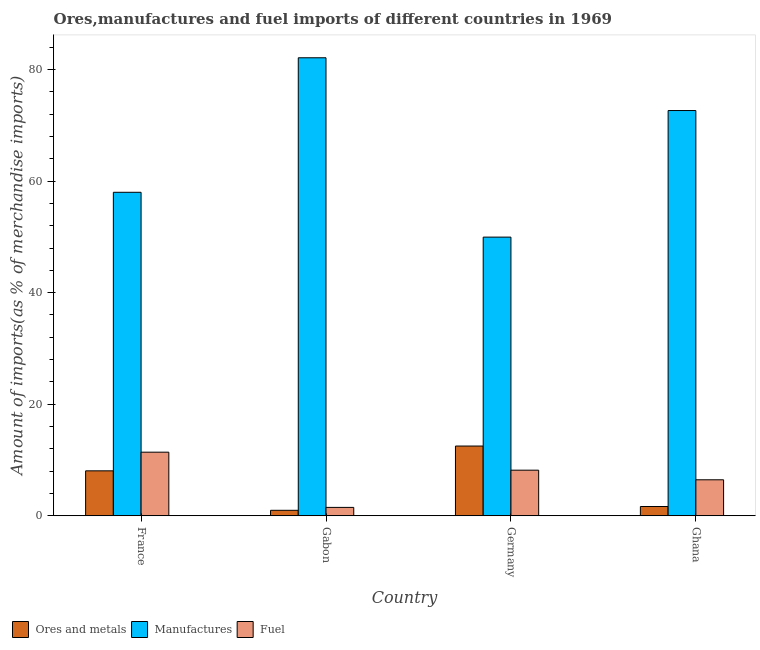How many bars are there on the 4th tick from the right?
Ensure brevity in your answer.  3. What is the label of the 3rd group of bars from the left?
Your response must be concise. Germany. What is the percentage of manufactures imports in Gabon?
Your response must be concise. 82.11. Across all countries, what is the maximum percentage of ores and metals imports?
Your answer should be compact. 12.5. Across all countries, what is the minimum percentage of ores and metals imports?
Offer a very short reply. 0.98. In which country was the percentage of manufactures imports maximum?
Give a very brief answer. Gabon. In which country was the percentage of fuel imports minimum?
Ensure brevity in your answer.  Gabon. What is the total percentage of ores and metals imports in the graph?
Keep it short and to the point. 23.21. What is the difference between the percentage of fuel imports in France and that in Germany?
Give a very brief answer. 3.23. What is the difference between the percentage of ores and metals imports in Gabon and the percentage of fuel imports in Germany?
Your answer should be very brief. -7.19. What is the average percentage of ores and metals imports per country?
Ensure brevity in your answer.  5.8. What is the difference between the percentage of fuel imports and percentage of ores and metals imports in Germany?
Keep it short and to the point. -4.33. In how many countries, is the percentage of manufactures imports greater than 76 %?
Your answer should be compact. 1. What is the ratio of the percentage of ores and metals imports in France to that in Ghana?
Your response must be concise. 4.84. What is the difference between the highest and the second highest percentage of fuel imports?
Keep it short and to the point. 3.23. What is the difference between the highest and the lowest percentage of ores and metals imports?
Your response must be concise. 11.52. What does the 2nd bar from the left in France represents?
Give a very brief answer. Manufactures. What does the 2nd bar from the right in France represents?
Your answer should be compact. Manufactures. Is it the case that in every country, the sum of the percentage of ores and metals imports and percentage of manufactures imports is greater than the percentage of fuel imports?
Your answer should be compact. Yes. How many bars are there?
Ensure brevity in your answer.  12. How many countries are there in the graph?
Offer a terse response. 4. What is the difference between two consecutive major ticks on the Y-axis?
Your response must be concise. 20. Does the graph contain any zero values?
Your answer should be compact. No. Where does the legend appear in the graph?
Provide a succinct answer. Bottom left. How are the legend labels stacked?
Your answer should be very brief. Horizontal. What is the title of the graph?
Ensure brevity in your answer.  Ores,manufactures and fuel imports of different countries in 1969. Does "Liquid fuel" appear as one of the legend labels in the graph?
Make the answer very short. No. What is the label or title of the Y-axis?
Provide a succinct answer. Amount of imports(as % of merchandise imports). What is the Amount of imports(as % of merchandise imports) in Ores and metals in France?
Give a very brief answer. 8.06. What is the Amount of imports(as % of merchandise imports) in Manufactures in France?
Offer a terse response. 57.99. What is the Amount of imports(as % of merchandise imports) of Fuel in France?
Give a very brief answer. 11.4. What is the Amount of imports(as % of merchandise imports) in Ores and metals in Gabon?
Ensure brevity in your answer.  0.98. What is the Amount of imports(as % of merchandise imports) in Manufactures in Gabon?
Provide a short and direct response. 82.11. What is the Amount of imports(as % of merchandise imports) in Fuel in Gabon?
Provide a short and direct response. 1.51. What is the Amount of imports(as % of merchandise imports) in Ores and metals in Germany?
Give a very brief answer. 12.5. What is the Amount of imports(as % of merchandise imports) in Manufactures in Germany?
Offer a very short reply. 49.96. What is the Amount of imports(as % of merchandise imports) of Fuel in Germany?
Your answer should be compact. 8.18. What is the Amount of imports(as % of merchandise imports) in Ores and metals in Ghana?
Keep it short and to the point. 1.67. What is the Amount of imports(as % of merchandise imports) of Manufactures in Ghana?
Provide a succinct answer. 72.65. What is the Amount of imports(as % of merchandise imports) of Fuel in Ghana?
Offer a terse response. 6.45. Across all countries, what is the maximum Amount of imports(as % of merchandise imports) in Ores and metals?
Offer a very short reply. 12.5. Across all countries, what is the maximum Amount of imports(as % of merchandise imports) in Manufactures?
Offer a very short reply. 82.11. Across all countries, what is the maximum Amount of imports(as % of merchandise imports) in Fuel?
Your answer should be very brief. 11.4. Across all countries, what is the minimum Amount of imports(as % of merchandise imports) in Ores and metals?
Keep it short and to the point. 0.98. Across all countries, what is the minimum Amount of imports(as % of merchandise imports) in Manufactures?
Offer a very short reply. 49.96. Across all countries, what is the minimum Amount of imports(as % of merchandise imports) of Fuel?
Ensure brevity in your answer.  1.51. What is the total Amount of imports(as % of merchandise imports) of Ores and metals in the graph?
Provide a succinct answer. 23.21. What is the total Amount of imports(as % of merchandise imports) in Manufactures in the graph?
Ensure brevity in your answer.  262.72. What is the total Amount of imports(as % of merchandise imports) in Fuel in the graph?
Provide a short and direct response. 27.54. What is the difference between the Amount of imports(as % of merchandise imports) in Ores and metals in France and that in Gabon?
Make the answer very short. 7.08. What is the difference between the Amount of imports(as % of merchandise imports) of Manufactures in France and that in Gabon?
Provide a short and direct response. -24.12. What is the difference between the Amount of imports(as % of merchandise imports) in Fuel in France and that in Gabon?
Make the answer very short. 9.9. What is the difference between the Amount of imports(as % of merchandise imports) in Ores and metals in France and that in Germany?
Your answer should be compact. -4.44. What is the difference between the Amount of imports(as % of merchandise imports) of Manufactures in France and that in Germany?
Offer a terse response. 8.03. What is the difference between the Amount of imports(as % of merchandise imports) of Fuel in France and that in Germany?
Offer a terse response. 3.23. What is the difference between the Amount of imports(as % of merchandise imports) of Ores and metals in France and that in Ghana?
Give a very brief answer. 6.39. What is the difference between the Amount of imports(as % of merchandise imports) in Manufactures in France and that in Ghana?
Your answer should be compact. -14.66. What is the difference between the Amount of imports(as % of merchandise imports) in Fuel in France and that in Ghana?
Make the answer very short. 4.95. What is the difference between the Amount of imports(as % of merchandise imports) of Ores and metals in Gabon and that in Germany?
Provide a short and direct response. -11.52. What is the difference between the Amount of imports(as % of merchandise imports) of Manufactures in Gabon and that in Germany?
Offer a very short reply. 32.15. What is the difference between the Amount of imports(as % of merchandise imports) of Fuel in Gabon and that in Germany?
Provide a short and direct response. -6.67. What is the difference between the Amount of imports(as % of merchandise imports) of Ores and metals in Gabon and that in Ghana?
Provide a succinct answer. -0.68. What is the difference between the Amount of imports(as % of merchandise imports) in Manufactures in Gabon and that in Ghana?
Give a very brief answer. 9.46. What is the difference between the Amount of imports(as % of merchandise imports) in Fuel in Gabon and that in Ghana?
Provide a short and direct response. -4.95. What is the difference between the Amount of imports(as % of merchandise imports) in Ores and metals in Germany and that in Ghana?
Offer a terse response. 10.84. What is the difference between the Amount of imports(as % of merchandise imports) of Manufactures in Germany and that in Ghana?
Your answer should be compact. -22.69. What is the difference between the Amount of imports(as % of merchandise imports) in Fuel in Germany and that in Ghana?
Keep it short and to the point. 1.72. What is the difference between the Amount of imports(as % of merchandise imports) in Ores and metals in France and the Amount of imports(as % of merchandise imports) in Manufactures in Gabon?
Your response must be concise. -74.05. What is the difference between the Amount of imports(as % of merchandise imports) of Ores and metals in France and the Amount of imports(as % of merchandise imports) of Fuel in Gabon?
Give a very brief answer. 6.55. What is the difference between the Amount of imports(as % of merchandise imports) of Manufactures in France and the Amount of imports(as % of merchandise imports) of Fuel in Gabon?
Your response must be concise. 56.49. What is the difference between the Amount of imports(as % of merchandise imports) in Ores and metals in France and the Amount of imports(as % of merchandise imports) in Manufactures in Germany?
Make the answer very short. -41.9. What is the difference between the Amount of imports(as % of merchandise imports) of Ores and metals in France and the Amount of imports(as % of merchandise imports) of Fuel in Germany?
Provide a short and direct response. -0.12. What is the difference between the Amount of imports(as % of merchandise imports) of Manufactures in France and the Amount of imports(as % of merchandise imports) of Fuel in Germany?
Provide a short and direct response. 49.82. What is the difference between the Amount of imports(as % of merchandise imports) of Ores and metals in France and the Amount of imports(as % of merchandise imports) of Manufactures in Ghana?
Provide a succinct answer. -64.59. What is the difference between the Amount of imports(as % of merchandise imports) in Ores and metals in France and the Amount of imports(as % of merchandise imports) in Fuel in Ghana?
Offer a very short reply. 1.61. What is the difference between the Amount of imports(as % of merchandise imports) of Manufactures in France and the Amount of imports(as % of merchandise imports) of Fuel in Ghana?
Provide a succinct answer. 51.54. What is the difference between the Amount of imports(as % of merchandise imports) of Ores and metals in Gabon and the Amount of imports(as % of merchandise imports) of Manufactures in Germany?
Your answer should be very brief. -48.98. What is the difference between the Amount of imports(as % of merchandise imports) of Ores and metals in Gabon and the Amount of imports(as % of merchandise imports) of Fuel in Germany?
Offer a terse response. -7.19. What is the difference between the Amount of imports(as % of merchandise imports) of Manufactures in Gabon and the Amount of imports(as % of merchandise imports) of Fuel in Germany?
Provide a succinct answer. 73.93. What is the difference between the Amount of imports(as % of merchandise imports) in Ores and metals in Gabon and the Amount of imports(as % of merchandise imports) in Manufactures in Ghana?
Provide a succinct answer. -71.67. What is the difference between the Amount of imports(as % of merchandise imports) of Ores and metals in Gabon and the Amount of imports(as % of merchandise imports) of Fuel in Ghana?
Offer a terse response. -5.47. What is the difference between the Amount of imports(as % of merchandise imports) in Manufactures in Gabon and the Amount of imports(as % of merchandise imports) in Fuel in Ghana?
Ensure brevity in your answer.  75.66. What is the difference between the Amount of imports(as % of merchandise imports) in Ores and metals in Germany and the Amount of imports(as % of merchandise imports) in Manufactures in Ghana?
Keep it short and to the point. -60.15. What is the difference between the Amount of imports(as % of merchandise imports) in Ores and metals in Germany and the Amount of imports(as % of merchandise imports) in Fuel in Ghana?
Offer a very short reply. 6.05. What is the difference between the Amount of imports(as % of merchandise imports) of Manufactures in Germany and the Amount of imports(as % of merchandise imports) of Fuel in Ghana?
Provide a succinct answer. 43.51. What is the average Amount of imports(as % of merchandise imports) in Ores and metals per country?
Offer a terse response. 5.8. What is the average Amount of imports(as % of merchandise imports) in Manufactures per country?
Ensure brevity in your answer.  65.68. What is the average Amount of imports(as % of merchandise imports) of Fuel per country?
Keep it short and to the point. 6.89. What is the difference between the Amount of imports(as % of merchandise imports) of Ores and metals and Amount of imports(as % of merchandise imports) of Manufactures in France?
Offer a terse response. -49.93. What is the difference between the Amount of imports(as % of merchandise imports) of Ores and metals and Amount of imports(as % of merchandise imports) of Fuel in France?
Provide a short and direct response. -3.34. What is the difference between the Amount of imports(as % of merchandise imports) in Manufactures and Amount of imports(as % of merchandise imports) in Fuel in France?
Make the answer very short. 46.59. What is the difference between the Amount of imports(as % of merchandise imports) of Ores and metals and Amount of imports(as % of merchandise imports) of Manufactures in Gabon?
Your answer should be very brief. -81.13. What is the difference between the Amount of imports(as % of merchandise imports) in Ores and metals and Amount of imports(as % of merchandise imports) in Fuel in Gabon?
Your response must be concise. -0.52. What is the difference between the Amount of imports(as % of merchandise imports) of Manufactures and Amount of imports(as % of merchandise imports) of Fuel in Gabon?
Ensure brevity in your answer.  80.6. What is the difference between the Amount of imports(as % of merchandise imports) of Ores and metals and Amount of imports(as % of merchandise imports) of Manufactures in Germany?
Provide a succinct answer. -37.46. What is the difference between the Amount of imports(as % of merchandise imports) of Ores and metals and Amount of imports(as % of merchandise imports) of Fuel in Germany?
Your response must be concise. 4.33. What is the difference between the Amount of imports(as % of merchandise imports) of Manufactures and Amount of imports(as % of merchandise imports) of Fuel in Germany?
Offer a very short reply. 41.78. What is the difference between the Amount of imports(as % of merchandise imports) of Ores and metals and Amount of imports(as % of merchandise imports) of Manufactures in Ghana?
Offer a very short reply. -70.99. What is the difference between the Amount of imports(as % of merchandise imports) in Ores and metals and Amount of imports(as % of merchandise imports) in Fuel in Ghana?
Your response must be concise. -4.79. What is the difference between the Amount of imports(as % of merchandise imports) in Manufactures and Amount of imports(as % of merchandise imports) in Fuel in Ghana?
Provide a succinct answer. 66.2. What is the ratio of the Amount of imports(as % of merchandise imports) of Ores and metals in France to that in Gabon?
Offer a very short reply. 8.19. What is the ratio of the Amount of imports(as % of merchandise imports) in Manufactures in France to that in Gabon?
Offer a very short reply. 0.71. What is the ratio of the Amount of imports(as % of merchandise imports) of Fuel in France to that in Gabon?
Keep it short and to the point. 7.57. What is the ratio of the Amount of imports(as % of merchandise imports) in Ores and metals in France to that in Germany?
Offer a very short reply. 0.64. What is the ratio of the Amount of imports(as % of merchandise imports) in Manufactures in France to that in Germany?
Give a very brief answer. 1.16. What is the ratio of the Amount of imports(as % of merchandise imports) of Fuel in France to that in Germany?
Your response must be concise. 1.39. What is the ratio of the Amount of imports(as % of merchandise imports) in Ores and metals in France to that in Ghana?
Provide a succinct answer. 4.84. What is the ratio of the Amount of imports(as % of merchandise imports) of Manufactures in France to that in Ghana?
Your answer should be compact. 0.8. What is the ratio of the Amount of imports(as % of merchandise imports) of Fuel in France to that in Ghana?
Keep it short and to the point. 1.77. What is the ratio of the Amount of imports(as % of merchandise imports) of Ores and metals in Gabon to that in Germany?
Your answer should be compact. 0.08. What is the ratio of the Amount of imports(as % of merchandise imports) in Manufactures in Gabon to that in Germany?
Your answer should be very brief. 1.64. What is the ratio of the Amount of imports(as % of merchandise imports) of Fuel in Gabon to that in Germany?
Your answer should be compact. 0.18. What is the ratio of the Amount of imports(as % of merchandise imports) in Ores and metals in Gabon to that in Ghana?
Your answer should be compact. 0.59. What is the ratio of the Amount of imports(as % of merchandise imports) in Manufactures in Gabon to that in Ghana?
Offer a very short reply. 1.13. What is the ratio of the Amount of imports(as % of merchandise imports) in Fuel in Gabon to that in Ghana?
Make the answer very short. 0.23. What is the ratio of the Amount of imports(as % of merchandise imports) of Ores and metals in Germany to that in Ghana?
Offer a very short reply. 7.51. What is the ratio of the Amount of imports(as % of merchandise imports) in Manufactures in Germany to that in Ghana?
Your answer should be very brief. 0.69. What is the ratio of the Amount of imports(as % of merchandise imports) in Fuel in Germany to that in Ghana?
Keep it short and to the point. 1.27. What is the difference between the highest and the second highest Amount of imports(as % of merchandise imports) of Ores and metals?
Provide a succinct answer. 4.44. What is the difference between the highest and the second highest Amount of imports(as % of merchandise imports) in Manufactures?
Ensure brevity in your answer.  9.46. What is the difference between the highest and the second highest Amount of imports(as % of merchandise imports) of Fuel?
Offer a terse response. 3.23. What is the difference between the highest and the lowest Amount of imports(as % of merchandise imports) of Ores and metals?
Provide a short and direct response. 11.52. What is the difference between the highest and the lowest Amount of imports(as % of merchandise imports) of Manufactures?
Offer a very short reply. 32.15. What is the difference between the highest and the lowest Amount of imports(as % of merchandise imports) of Fuel?
Make the answer very short. 9.9. 